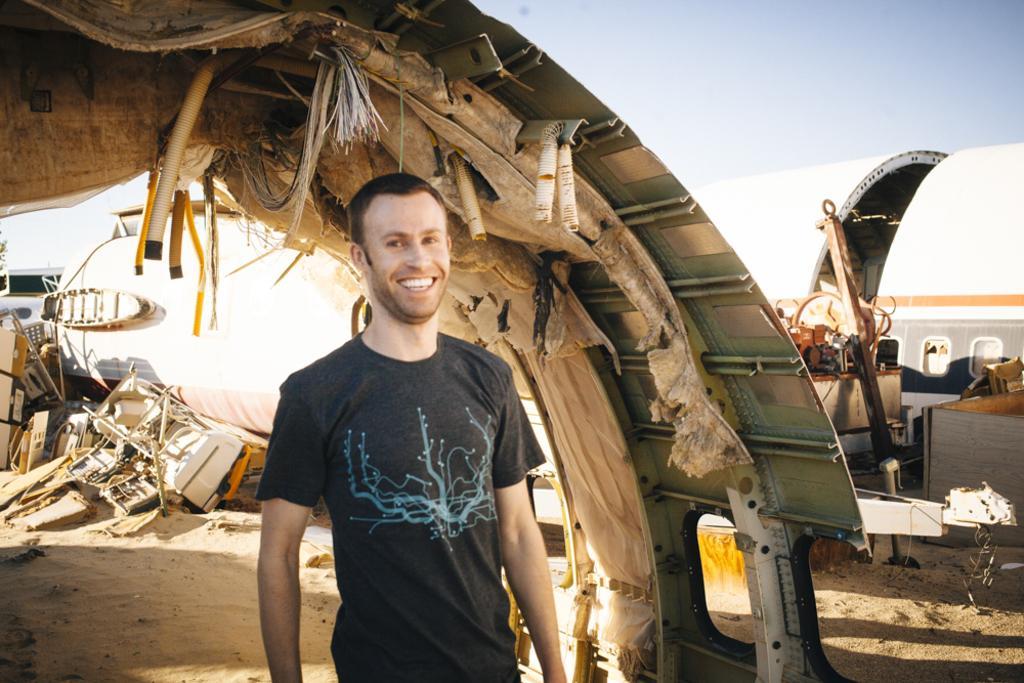How would you summarize this image in a sentence or two? The man in the middle of the picture is standing and he is smiling. Behind him, we see something like a shed. Behind him, we see many carton boxes and wooden things. In the background, we see an object in white color. On the right side, we see the machinery equipment. At the top, we see the sky. 